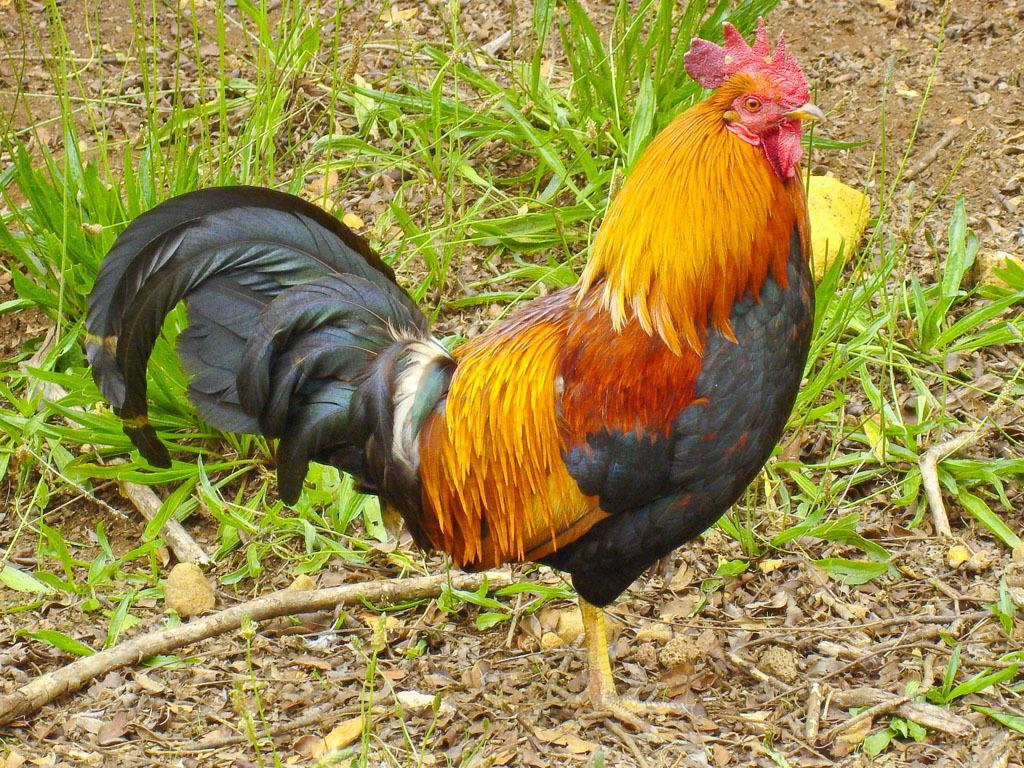What type of animal is in the image? There is a cock in the image. What is the cock's position in relation to the ground? The cock is standing on the ground. What type of vegetation is near the cock? The cock is beside the grass. What type of ear can be seen on the cock in the image? There is no ear visible on the cock in the image, as cocks do not have ears like humans. 